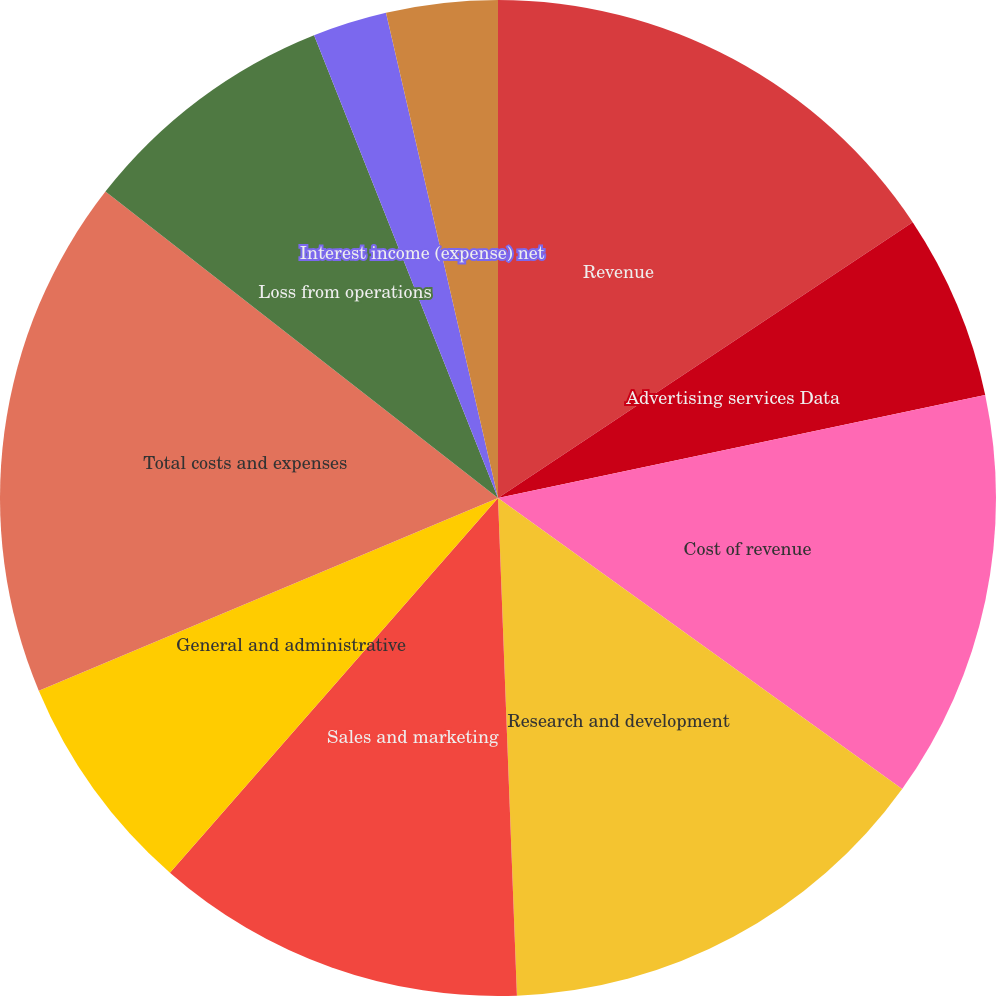<chart> <loc_0><loc_0><loc_500><loc_500><pie_chart><fcel>Revenue<fcel>Advertising services Data<fcel>Cost of revenue<fcel>Research and development<fcel>Sales and marketing<fcel>General and administrative<fcel>Total costs and expenses<fcel>Loss from operations<fcel>Interest income (expense) net<fcel>Other income (expense) net<nl><fcel>15.66%<fcel>6.02%<fcel>13.25%<fcel>14.46%<fcel>12.05%<fcel>7.23%<fcel>16.87%<fcel>8.43%<fcel>2.41%<fcel>3.61%<nl></chart> 